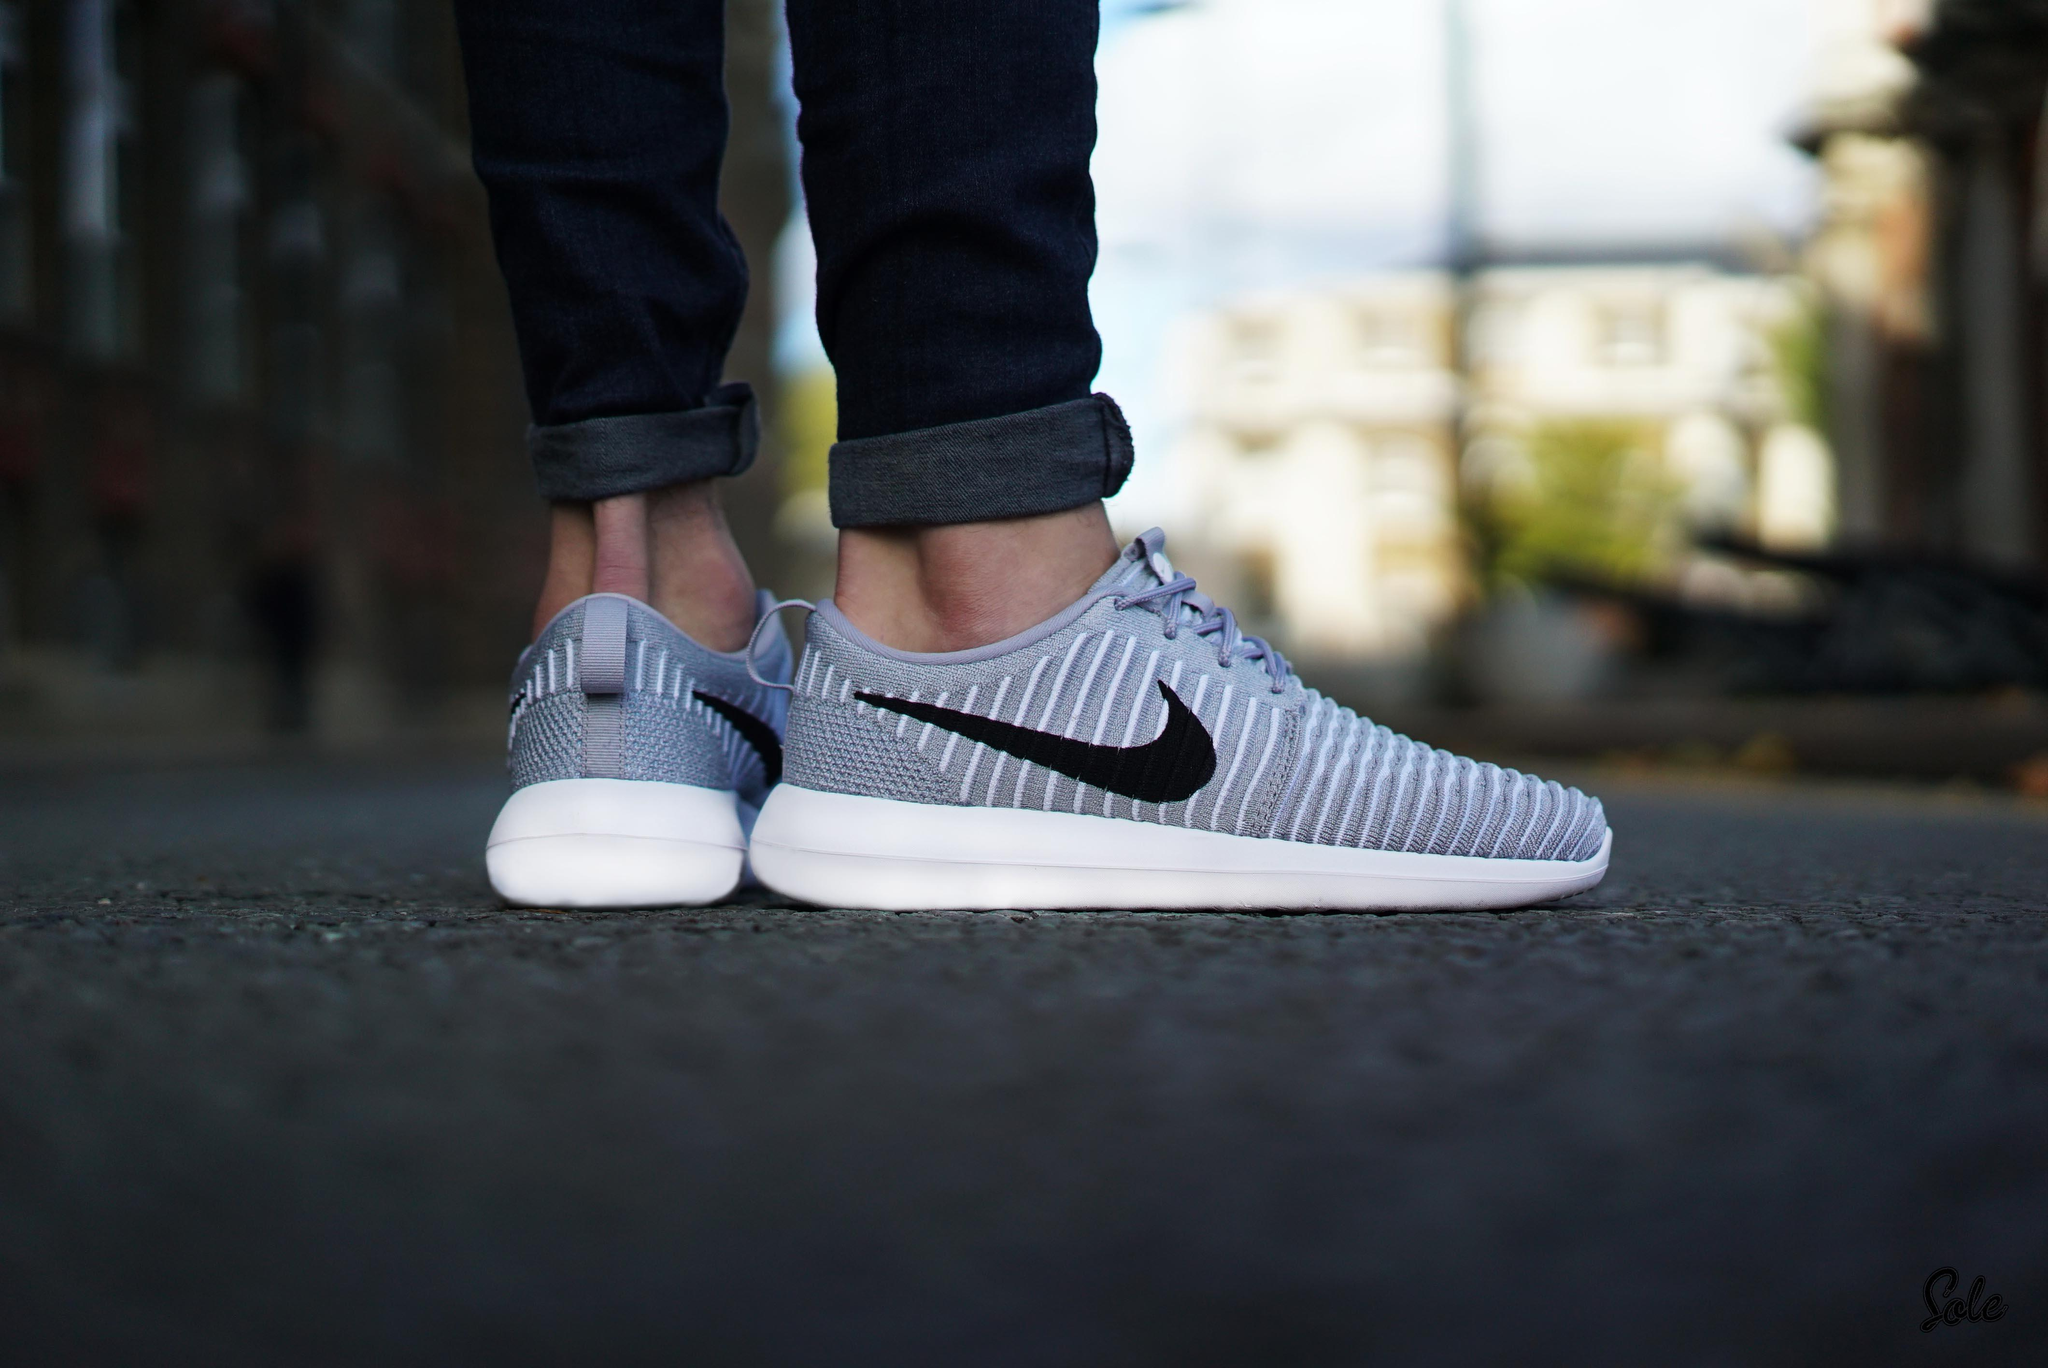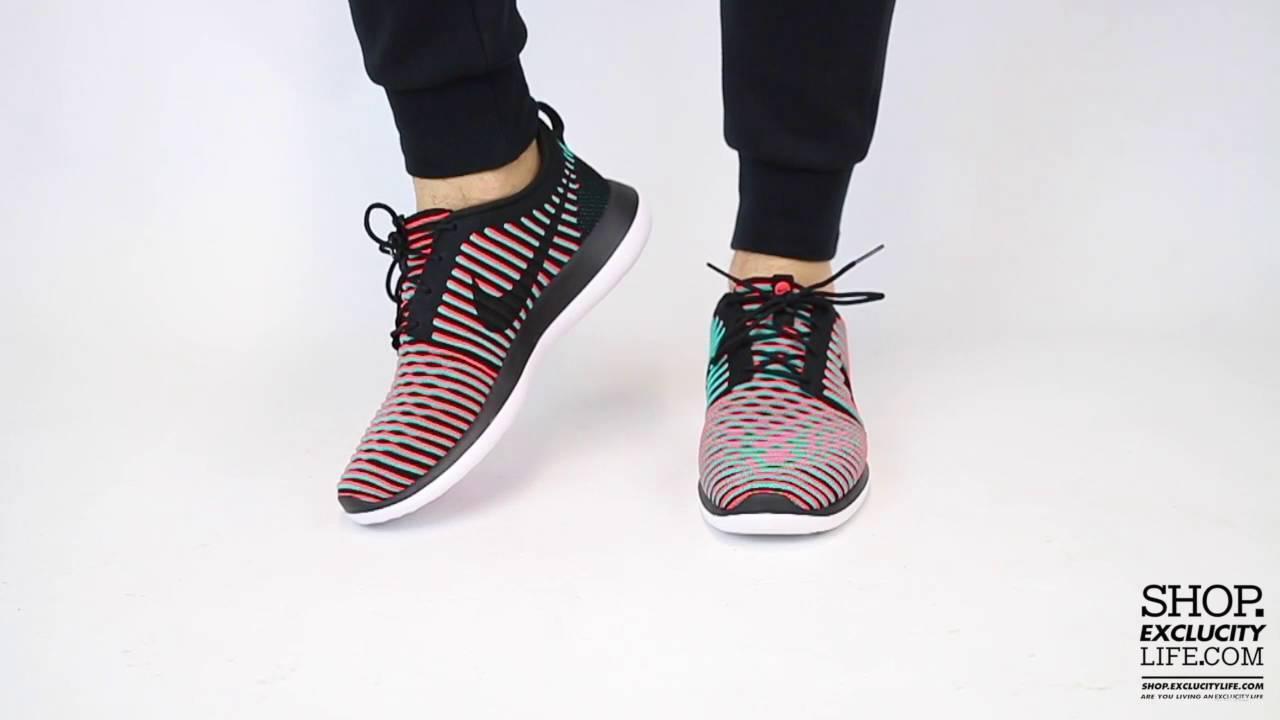The first image is the image on the left, the second image is the image on the right. Considering the images on both sides, is "The person in the image on the left is standing with both feet planted firmly a hard surface." valid? Answer yes or no. Yes. The first image is the image on the left, the second image is the image on the right. Given the left and right images, does the statement "An image shows a pair of sneaker-wearing feet flat on the ground on an outdoor surface." hold true? Answer yes or no. Yes. 